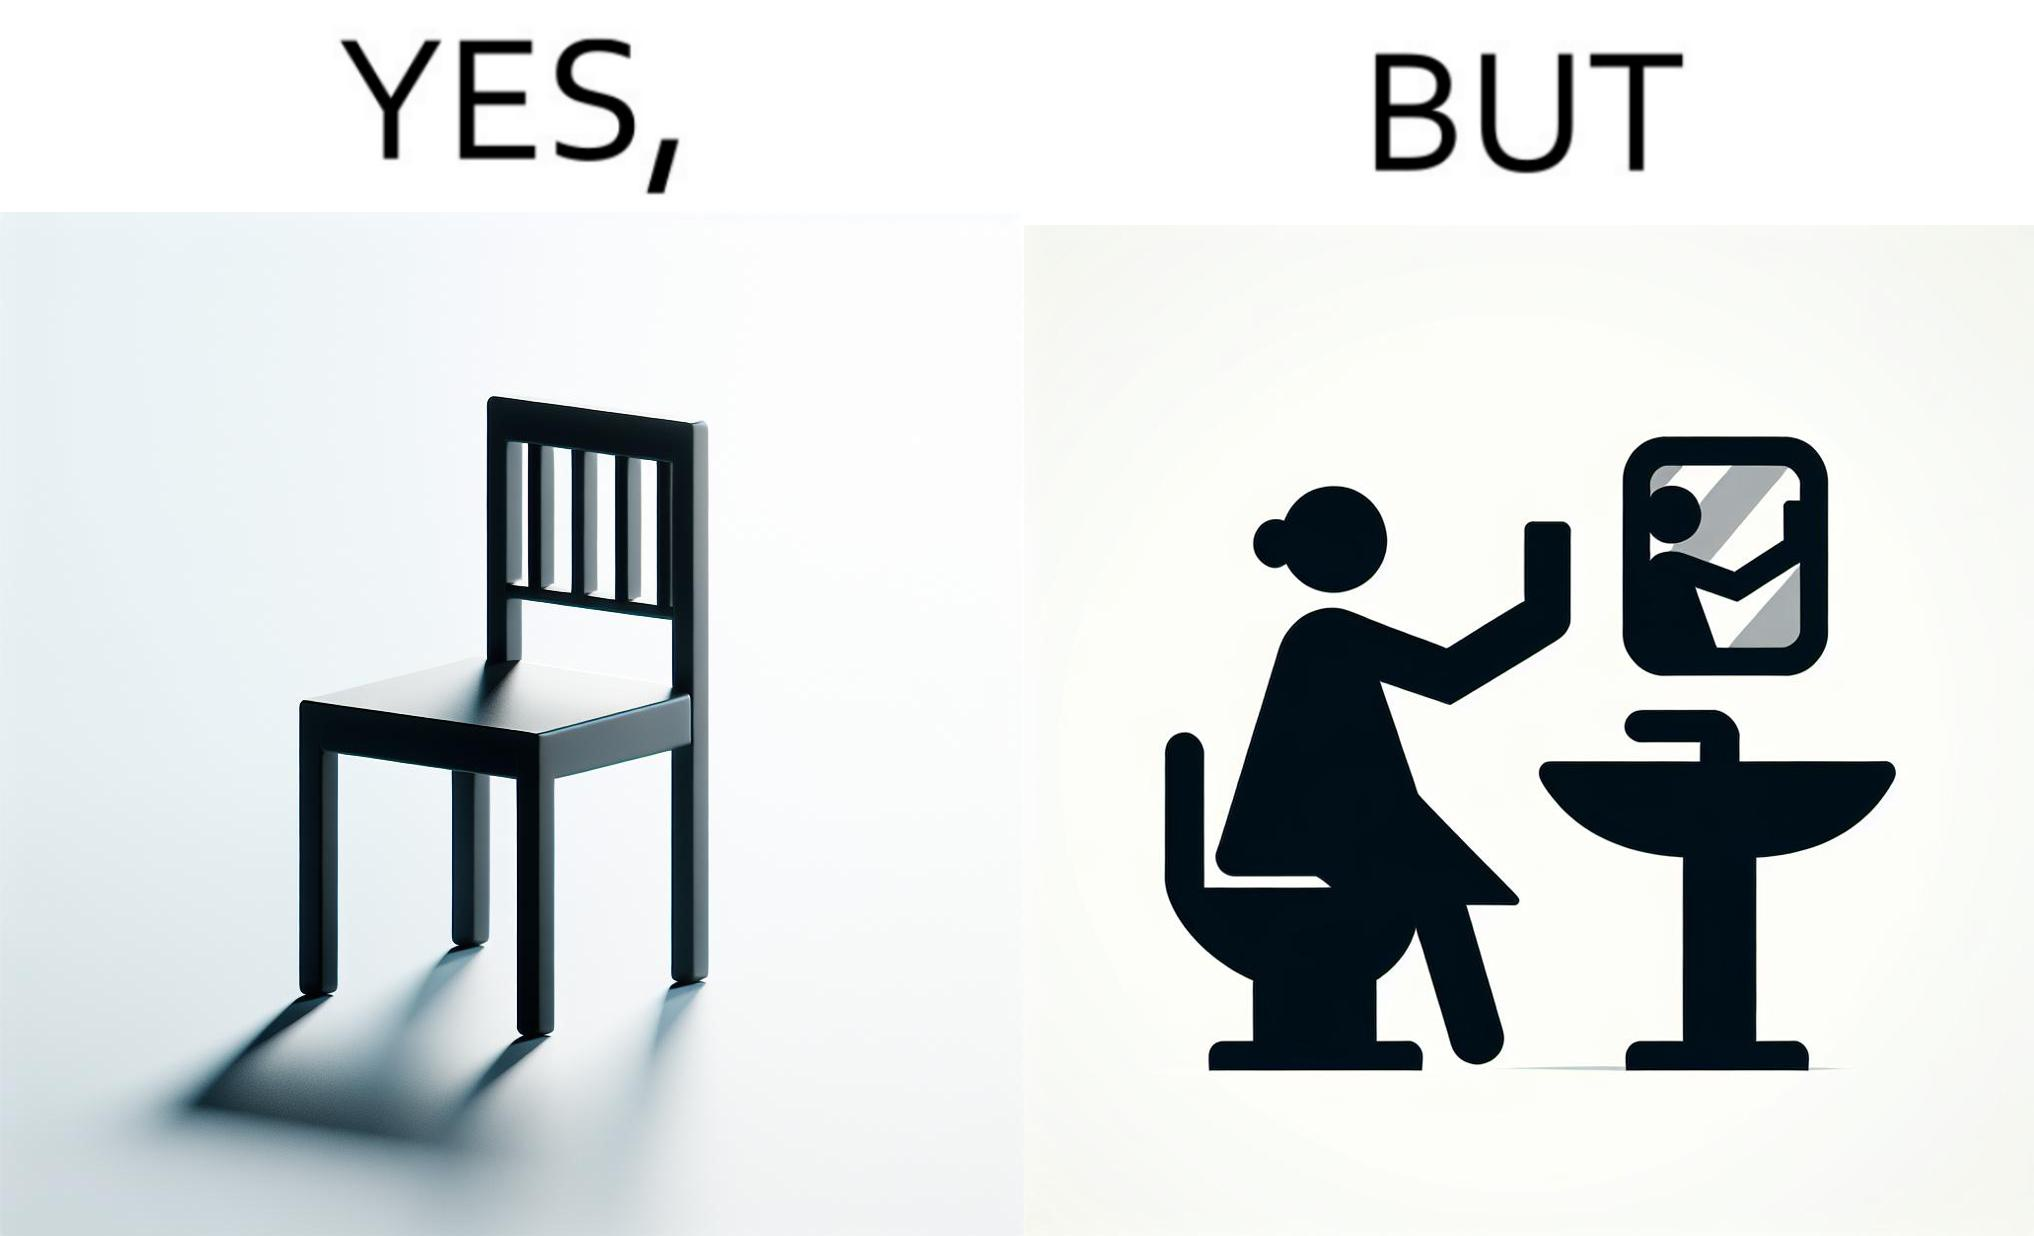Is this image satirical or non-satirical? Yes, this image is satirical. 